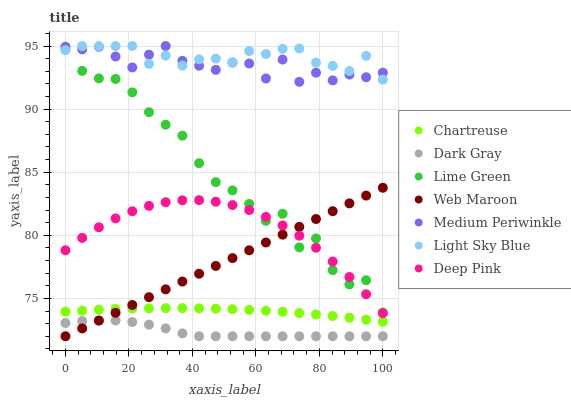Does Dark Gray have the minimum area under the curve?
Answer yes or no. Yes. Does Light Sky Blue have the maximum area under the curve?
Answer yes or no. Yes. Does Medium Periwinkle have the minimum area under the curve?
Answer yes or no. No. Does Medium Periwinkle have the maximum area under the curve?
Answer yes or no. No. Is Web Maroon the smoothest?
Answer yes or no. Yes. Is Lime Green the roughest?
Answer yes or no. Yes. Is Medium Periwinkle the smoothest?
Answer yes or no. No. Is Medium Periwinkle the roughest?
Answer yes or no. No. Does Web Maroon have the lowest value?
Answer yes or no. Yes. Does Medium Periwinkle have the lowest value?
Answer yes or no. No. Does Light Sky Blue have the highest value?
Answer yes or no. Yes. Does Web Maroon have the highest value?
Answer yes or no. No. Is Chartreuse less than Light Sky Blue?
Answer yes or no. Yes. Is Medium Periwinkle greater than Lime Green?
Answer yes or no. Yes. Does Web Maroon intersect Chartreuse?
Answer yes or no. Yes. Is Web Maroon less than Chartreuse?
Answer yes or no. No. Is Web Maroon greater than Chartreuse?
Answer yes or no. No. Does Chartreuse intersect Light Sky Blue?
Answer yes or no. No. 